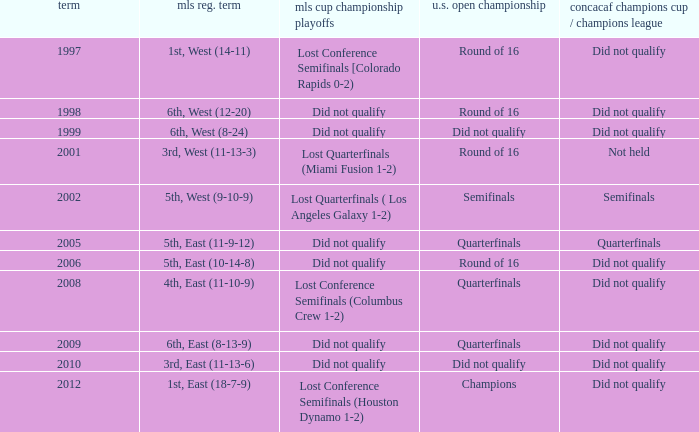How did the team place when they did not qualify for the Concaf Champions Cup but made it to Round of 16 in the U.S. Open Cup? Lost Conference Semifinals [Colorado Rapids 0-2), Did not qualify, Did not qualify. 